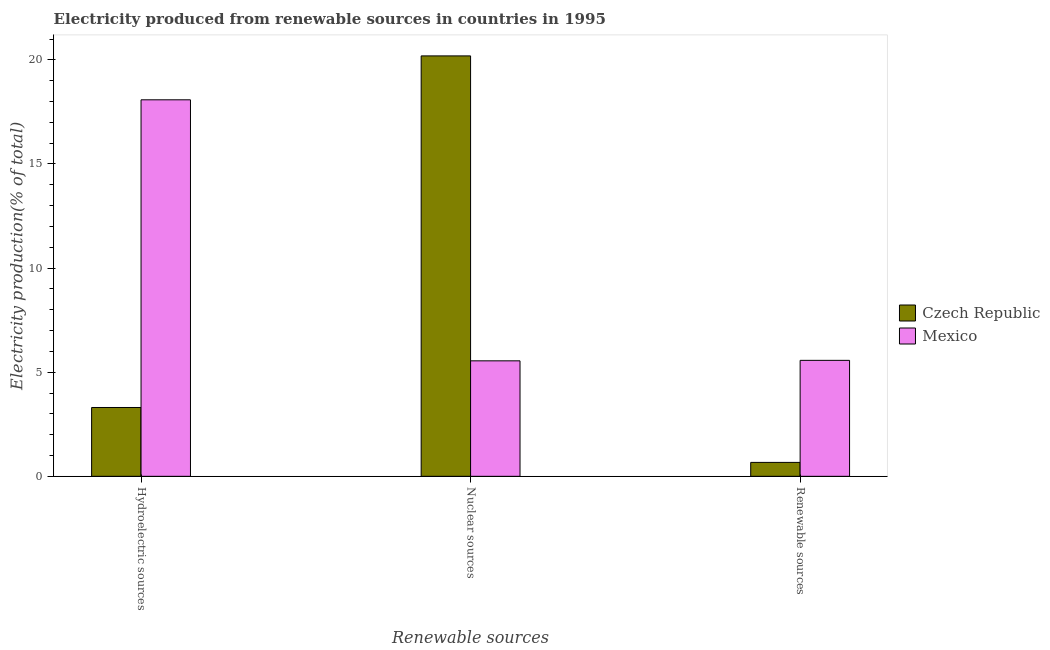How many different coloured bars are there?
Offer a terse response. 2. How many groups of bars are there?
Keep it short and to the point. 3. Are the number of bars per tick equal to the number of legend labels?
Your response must be concise. Yes. Are the number of bars on each tick of the X-axis equal?
Ensure brevity in your answer.  Yes. What is the label of the 1st group of bars from the left?
Ensure brevity in your answer.  Hydroelectric sources. What is the percentage of electricity produced by hydroelectric sources in Czech Republic?
Offer a terse response. 3.3. Across all countries, what is the maximum percentage of electricity produced by hydroelectric sources?
Give a very brief answer. 18.08. Across all countries, what is the minimum percentage of electricity produced by renewable sources?
Ensure brevity in your answer.  0.67. In which country was the percentage of electricity produced by renewable sources minimum?
Offer a very short reply. Czech Republic. What is the total percentage of electricity produced by nuclear sources in the graph?
Make the answer very short. 25.74. What is the difference between the percentage of electricity produced by hydroelectric sources in Czech Republic and that in Mexico?
Ensure brevity in your answer.  -14.78. What is the difference between the percentage of electricity produced by renewable sources in Mexico and the percentage of electricity produced by hydroelectric sources in Czech Republic?
Give a very brief answer. 2.26. What is the average percentage of electricity produced by hydroelectric sources per country?
Keep it short and to the point. 10.69. What is the difference between the percentage of electricity produced by nuclear sources and percentage of electricity produced by renewable sources in Czech Republic?
Give a very brief answer. 19.52. In how many countries, is the percentage of electricity produced by nuclear sources greater than 17 %?
Keep it short and to the point. 1. What is the ratio of the percentage of electricity produced by renewable sources in Mexico to that in Czech Republic?
Offer a terse response. 8.33. What is the difference between the highest and the second highest percentage of electricity produced by nuclear sources?
Keep it short and to the point. 14.64. What is the difference between the highest and the lowest percentage of electricity produced by hydroelectric sources?
Keep it short and to the point. 14.78. What does the 1st bar from the right in Renewable sources represents?
Provide a short and direct response. Mexico. Is it the case that in every country, the sum of the percentage of electricity produced by hydroelectric sources and percentage of electricity produced by nuclear sources is greater than the percentage of electricity produced by renewable sources?
Provide a succinct answer. Yes. Are all the bars in the graph horizontal?
Your answer should be compact. No. How many countries are there in the graph?
Your answer should be compact. 2. What is the difference between two consecutive major ticks on the Y-axis?
Your answer should be compact. 5. Does the graph contain any zero values?
Provide a short and direct response. No. Does the graph contain grids?
Your answer should be compact. No. How are the legend labels stacked?
Your response must be concise. Vertical. What is the title of the graph?
Offer a very short reply. Electricity produced from renewable sources in countries in 1995. Does "Europe(developing only)" appear as one of the legend labels in the graph?
Keep it short and to the point. No. What is the label or title of the X-axis?
Ensure brevity in your answer.  Renewable sources. What is the Electricity production(% of total) of Czech Republic in Hydroelectric sources?
Provide a short and direct response. 3.3. What is the Electricity production(% of total) in Mexico in Hydroelectric sources?
Give a very brief answer. 18.08. What is the Electricity production(% of total) of Czech Republic in Nuclear sources?
Give a very brief answer. 20.19. What is the Electricity production(% of total) of Mexico in Nuclear sources?
Offer a terse response. 5.55. What is the Electricity production(% of total) in Czech Republic in Renewable sources?
Make the answer very short. 0.67. What is the Electricity production(% of total) of Mexico in Renewable sources?
Your response must be concise. 5.57. Across all Renewable sources, what is the maximum Electricity production(% of total) of Czech Republic?
Ensure brevity in your answer.  20.19. Across all Renewable sources, what is the maximum Electricity production(% of total) in Mexico?
Your answer should be compact. 18.08. Across all Renewable sources, what is the minimum Electricity production(% of total) of Czech Republic?
Ensure brevity in your answer.  0.67. Across all Renewable sources, what is the minimum Electricity production(% of total) in Mexico?
Your answer should be very brief. 5.55. What is the total Electricity production(% of total) in Czech Republic in the graph?
Provide a succinct answer. 24.16. What is the total Electricity production(% of total) in Mexico in the graph?
Keep it short and to the point. 29.2. What is the difference between the Electricity production(% of total) of Czech Republic in Hydroelectric sources and that in Nuclear sources?
Offer a very short reply. -16.88. What is the difference between the Electricity production(% of total) of Mexico in Hydroelectric sources and that in Nuclear sources?
Provide a succinct answer. 12.54. What is the difference between the Electricity production(% of total) in Czech Republic in Hydroelectric sources and that in Renewable sources?
Ensure brevity in your answer.  2.64. What is the difference between the Electricity production(% of total) of Mexico in Hydroelectric sources and that in Renewable sources?
Your response must be concise. 12.51. What is the difference between the Electricity production(% of total) of Czech Republic in Nuclear sources and that in Renewable sources?
Your response must be concise. 19.52. What is the difference between the Electricity production(% of total) in Mexico in Nuclear sources and that in Renewable sources?
Provide a succinct answer. -0.02. What is the difference between the Electricity production(% of total) in Czech Republic in Hydroelectric sources and the Electricity production(% of total) in Mexico in Nuclear sources?
Offer a very short reply. -2.24. What is the difference between the Electricity production(% of total) of Czech Republic in Hydroelectric sources and the Electricity production(% of total) of Mexico in Renewable sources?
Make the answer very short. -2.26. What is the difference between the Electricity production(% of total) of Czech Republic in Nuclear sources and the Electricity production(% of total) of Mexico in Renewable sources?
Offer a terse response. 14.62. What is the average Electricity production(% of total) of Czech Republic per Renewable sources?
Make the answer very short. 8.05. What is the average Electricity production(% of total) of Mexico per Renewable sources?
Make the answer very short. 9.73. What is the difference between the Electricity production(% of total) of Czech Republic and Electricity production(% of total) of Mexico in Hydroelectric sources?
Give a very brief answer. -14.78. What is the difference between the Electricity production(% of total) in Czech Republic and Electricity production(% of total) in Mexico in Nuclear sources?
Your answer should be very brief. 14.64. What is the difference between the Electricity production(% of total) in Czech Republic and Electricity production(% of total) in Mexico in Renewable sources?
Offer a very short reply. -4.9. What is the ratio of the Electricity production(% of total) of Czech Republic in Hydroelectric sources to that in Nuclear sources?
Provide a succinct answer. 0.16. What is the ratio of the Electricity production(% of total) of Mexico in Hydroelectric sources to that in Nuclear sources?
Your answer should be compact. 3.26. What is the ratio of the Electricity production(% of total) in Czech Republic in Hydroelectric sources to that in Renewable sources?
Your answer should be very brief. 4.94. What is the ratio of the Electricity production(% of total) in Mexico in Hydroelectric sources to that in Renewable sources?
Ensure brevity in your answer.  3.25. What is the ratio of the Electricity production(% of total) of Czech Republic in Nuclear sources to that in Renewable sources?
Make the answer very short. 30.2. What is the ratio of the Electricity production(% of total) in Mexico in Nuclear sources to that in Renewable sources?
Offer a terse response. 1. What is the difference between the highest and the second highest Electricity production(% of total) in Czech Republic?
Keep it short and to the point. 16.88. What is the difference between the highest and the second highest Electricity production(% of total) of Mexico?
Your answer should be compact. 12.51. What is the difference between the highest and the lowest Electricity production(% of total) in Czech Republic?
Your answer should be compact. 19.52. What is the difference between the highest and the lowest Electricity production(% of total) in Mexico?
Your answer should be very brief. 12.54. 